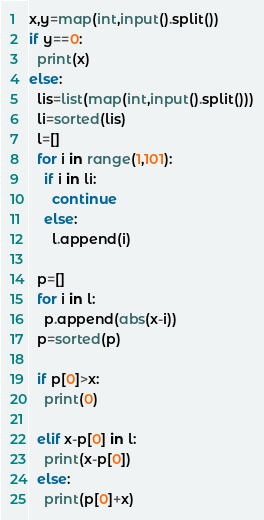<code> <loc_0><loc_0><loc_500><loc_500><_Python_>x,y=map(int,input().split())
if y==0:
  print(x)
else:
  lis=list(map(int,input().split()))
  li=sorted(lis)
  l=[]
  for i in range(1,101):
    if i in li:
      continue
    else:
      l.append(i)
  
  p=[]
  for i in l:
    p.append(abs(x-i))
  p=sorted(p)

  if p[0]>x:
    print(0)
  
  elif x-p[0] in l:
    print(x-p[0])
  else:
    print(p[0]+x)</code> 